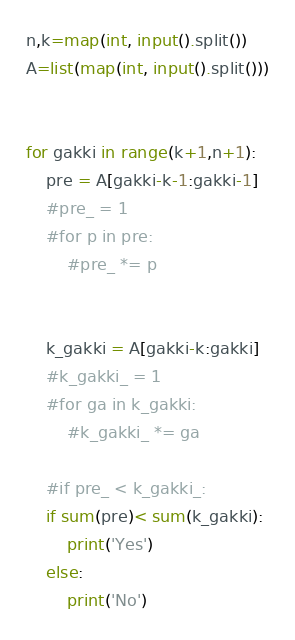<code> <loc_0><loc_0><loc_500><loc_500><_Python_>n,k=map(int, input().split())
A=list(map(int, input().split()))


for gakki in range(k+1,n+1):
    pre = A[gakki-k-1:gakki-1]
    #pre_ = 1
    #for p in pre:
        #pre_ *= p

    
    k_gakki = A[gakki-k:gakki]
    #k_gakki_ = 1
    #for ga in k_gakki:
        #k_gakki_ *= ga
    
    #if pre_ < k_gakki_:
    if sum(pre)< sum(k_gakki):
        print('Yes')
    else:
        print('No')</code> 